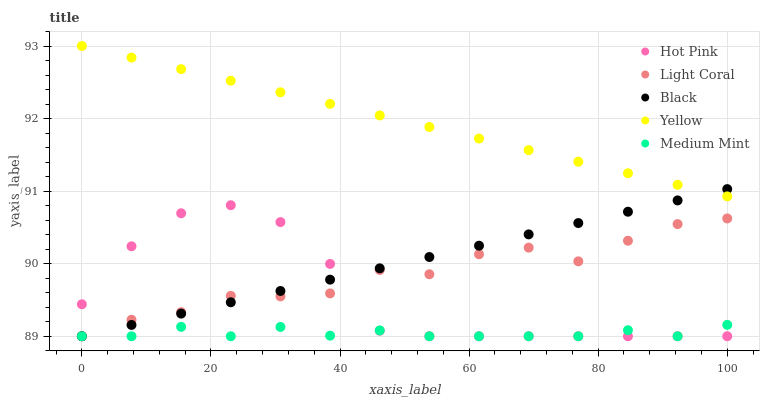Does Medium Mint have the minimum area under the curve?
Answer yes or no. Yes. Does Yellow have the maximum area under the curve?
Answer yes or no. Yes. Does Hot Pink have the minimum area under the curve?
Answer yes or no. No. Does Hot Pink have the maximum area under the curve?
Answer yes or no. No. Is Black the smoothest?
Answer yes or no. Yes. Is Light Coral the roughest?
Answer yes or no. Yes. Is Medium Mint the smoothest?
Answer yes or no. No. Is Medium Mint the roughest?
Answer yes or no. No. Does Light Coral have the lowest value?
Answer yes or no. Yes. Does Yellow have the lowest value?
Answer yes or no. No. Does Yellow have the highest value?
Answer yes or no. Yes. Does Hot Pink have the highest value?
Answer yes or no. No. Is Medium Mint less than Yellow?
Answer yes or no. Yes. Is Yellow greater than Hot Pink?
Answer yes or no. Yes. Does Medium Mint intersect Black?
Answer yes or no. Yes. Is Medium Mint less than Black?
Answer yes or no. No. Is Medium Mint greater than Black?
Answer yes or no. No. Does Medium Mint intersect Yellow?
Answer yes or no. No. 